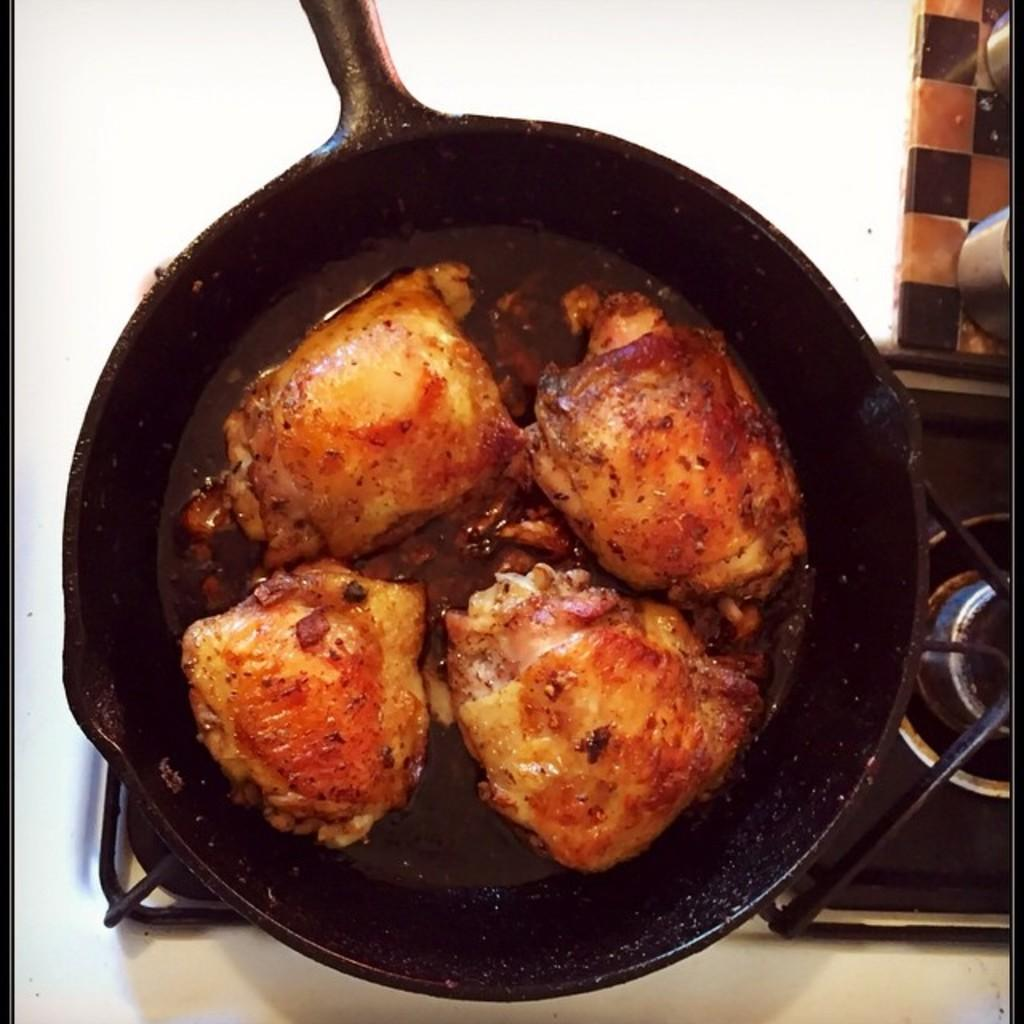What type of food item is in the black vessel? The fact does not specify the type of food item in the black vessel. Where is the black vessel located? The black vessel is on a glass stove. What color is the surface visible in the image? The surface visible in the image is white. What nerve is responsible for the aftermath of the rule in the image? There is no nerve, aftermath, or rule present in the image. 